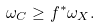Convert formula to latex. <formula><loc_0><loc_0><loc_500><loc_500>\omega _ { C } \geq f ^ { * } \omega _ { X } .</formula> 